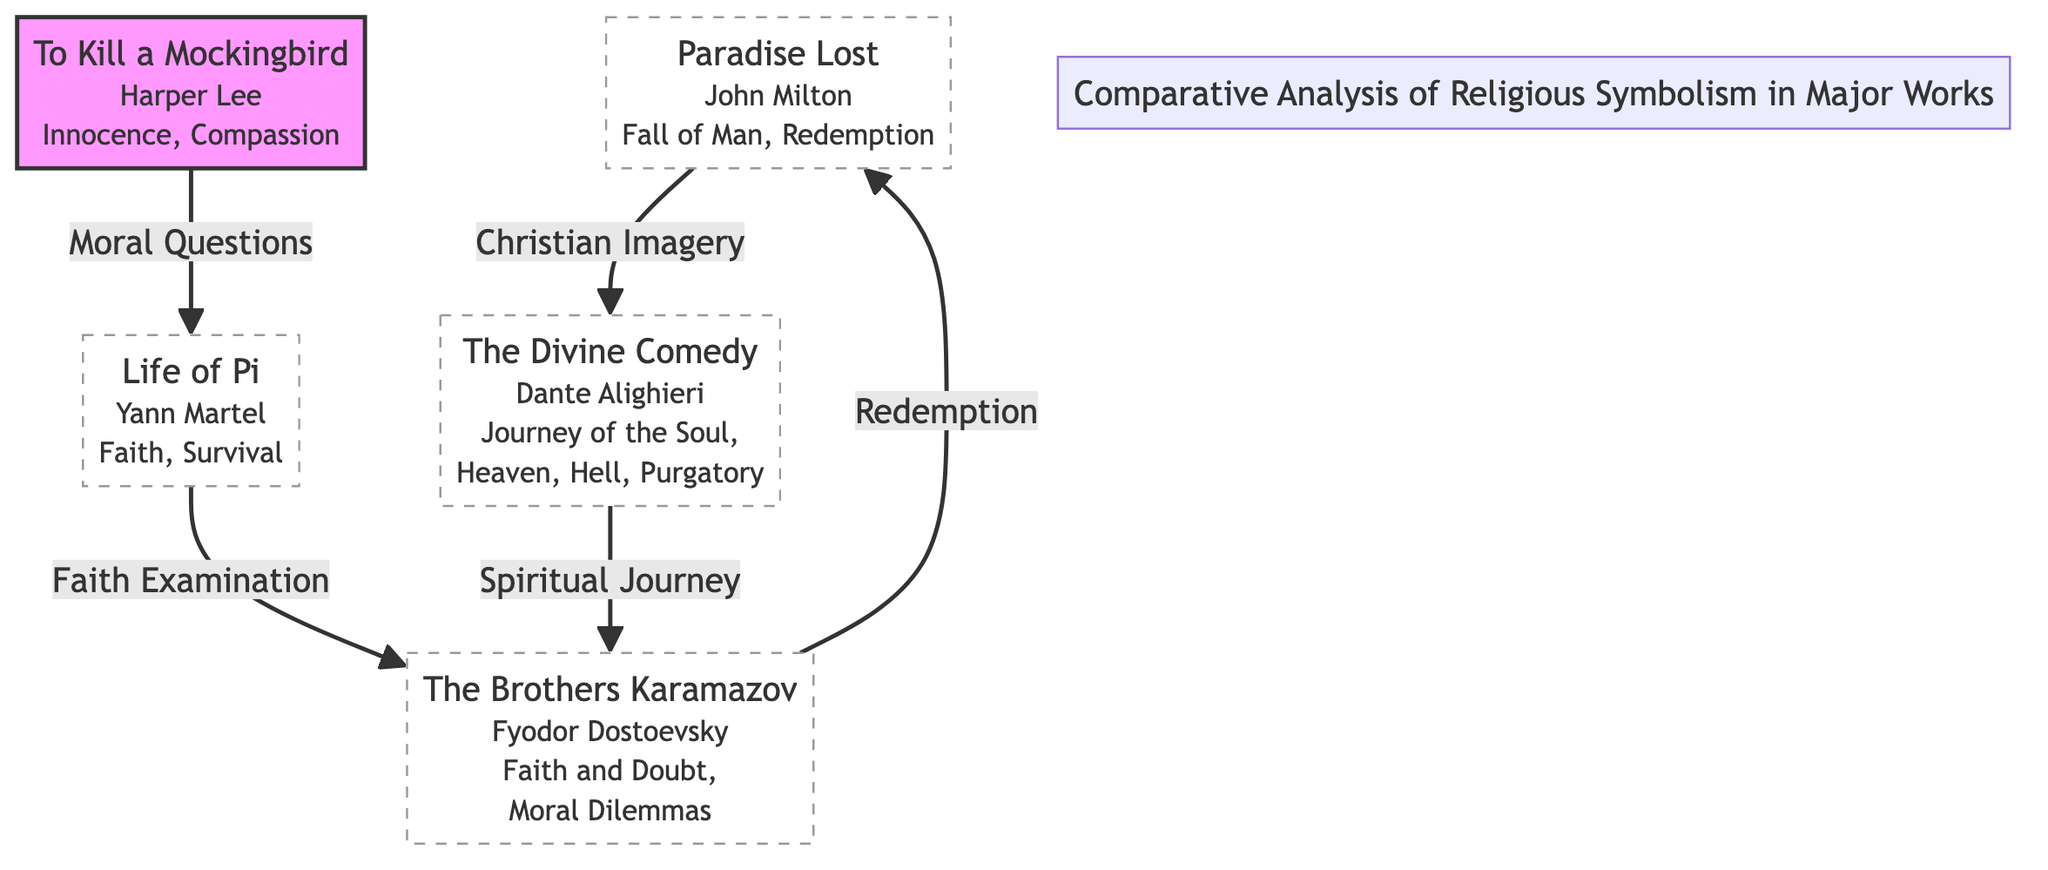What is the title of the book associated with "Faith and Doubt"? The node that represents "Faith and Doubt" points to "The Brothers Karamazov," which is indicated beneath that title in the diagram.
Answer: The Brothers Karamazov How many books are depicted in the diagram? There are five distinct nodes representing books in the diagram: "Paradise Lost," "The Divine Comedy," "The Brothers Karamazov," "To Kill a Mockingbird," and "Life of Pi."
Answer: 5 Which book is directly connected to "Christian Imagery"? In the diagram, "Christian Imagery" is an edge that connects "Paradise Lost" and "The Divine Comedy." Therefore, the book that is directly connected to "Christian Imagery" is "The Divine Comedy."
Answer: The Divine Comedy What concept links "Paradise Lost" to "The Brothers Karamazov"? The connection between these two books is labeled "Redemption," which shows the thematic link connecting them in the diagram.
Answer: Redemption Which two works share a connection about "Spiritual Journey"? The edge labeled "Spiritual Journey" connects "The Divine Comedy" and "The Brothers Karamazov," highlighting a thematic relationship between these two texts.
Answer: The Divine Comedy and The Brothers Karamazov What is the theme connecting "Life of Pi" and "To Kill a Mockingbird"? The edge between "Life of Pi" and "To Kill a Mockingbird" is labeled "Moral Questions," indicating the connection based on that theme.
Answer: Moral Questions Which book explores the theme of "Innocence, Compassion"? The node describing "Innocence, Compassion" refers specifically to "To Kill a Mockingbird," as shown in the diagram beneath that title.
Answer: To Kill a Mockingbird What links "Life of Pi" to "Brothers Karamazov"? The connection from "Life of Pi" to "Brothers Karamazov" is labeled "Faith Examination," marking their thematic relationship regarding faith.
Answer: Faith Examination How many direct connections does "The Divine Comedy" have? The diagram shows two connections stemming from "The Divine Comedy": one to "Paradise Lost" marked as "Christian Imagery," and another to "Brothers Karamazov" labeled "Spiritual Journey." Thus, it has two direct connections.
Answer: 2 